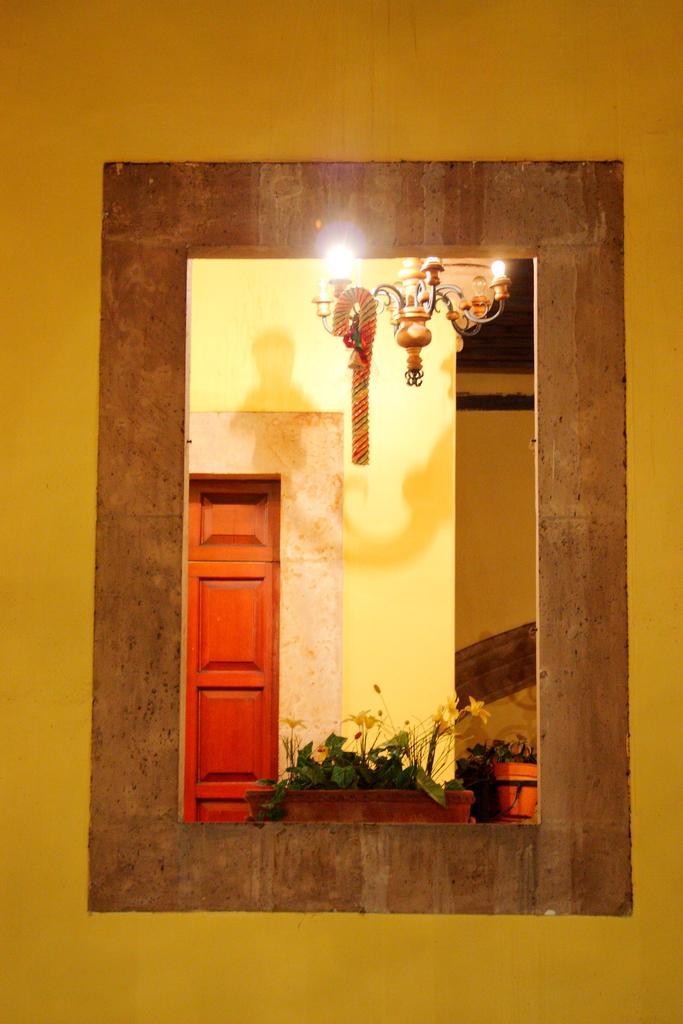Could you give a brief overview of what you see in this image? In the foreground of this image, there is a wall and a window. Through the window, we can see a door like an object, will, a chandelier and few plants. 